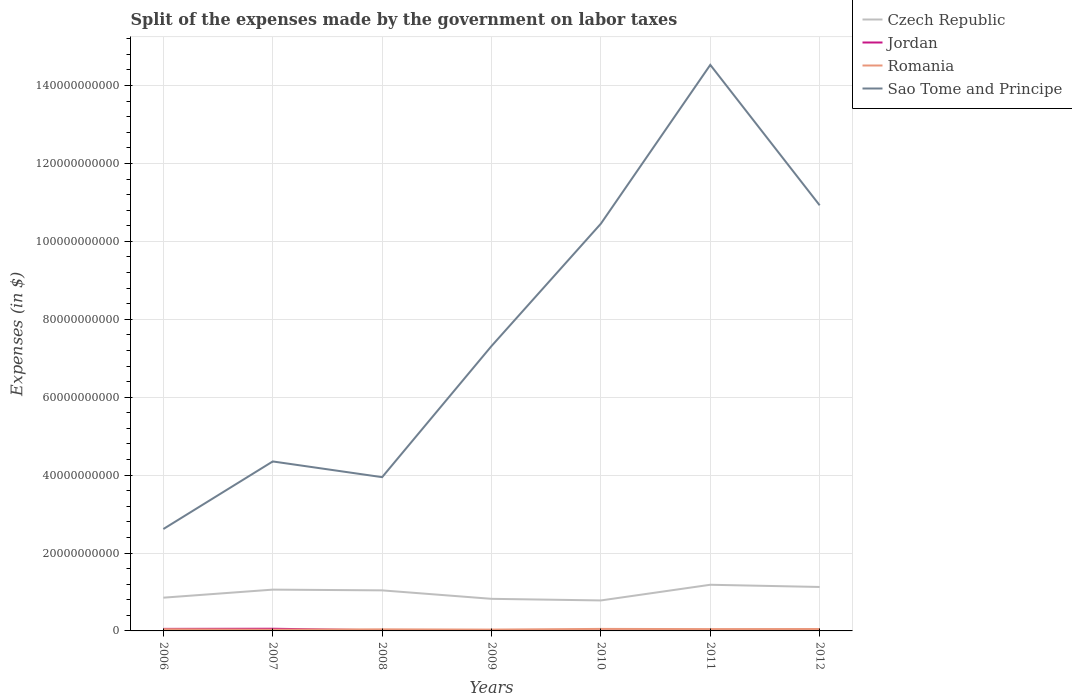How many different coloured lines are there?
Provide a succinct answer. 4. Is the number of lines equal to the number of legend labels?
Your response must be concise. Yes. Across all years, what is the maximum expenses made by the government on labor taxes in Sao Tome and Principe?
Provide a short and direct response. 2.62e+1. In which year was the expenses made by the government on labor taxes in Jordan maximum?
Offer a very short reply. 2011. What is the total expenses made by the government on labor taxes in Sao Tome and Principe in the graph?
Offer a terse response. -4.71e+09. What is the difference between the highest and the second highest expenses made by the government on labor taxes in Czech Republic?
Make the answer very short. 4.02e+09. Is the expenses made by the government on labor taxes in Romania strictly greater than the expenses made by the government on labor taxes in Jordan over the years?
Provide a short and direct response. No. How many lines are there?
Your answer should be very brief. 4. How many years are there in the graph?
Your response must be concise. 7. What is the difference between two consecutive major ticks on the Y-axis?
Offer a terse response. 2.00e+1. Are the values on the major ticks of Y-axis written in scientific E-notation?
Your answer should be very brief. No. Does the graph contain any zero values?
Keep it short and to the point. No. Does the graph contain grids?
Ensure brevity in your answer.  Yes. How many legend labels are there?
Provide a short and direct response. 4. How are the legend labels stacked?
Provide a succinct answer. Vertical. What is the title of the graph?
Your response must be concise. Split of the expenses made by the government on labor taxes. Does "Cuba" appear as one of the legend labels in the graph?
Ensure brevity in your answer.  No. What is the label or title of the X-axis?
Make the answer very short. Years. What is the label or title of the Y-axis?
Offer a very short reply. Expenses (in $). What is the Expenses (in $) in Czech Republic in 2006?
Your answer should be compact. 8.54e+09. What is the Expenses (in $) of Jordan in 2006?
Give a very brief answer. 5.26e+08. What is the Expenses (in $) in Romania in 2006?
Ensure brevity in your answer.  4.42e+08. What is the Expenses (in $) in Sao Tome and Principe in 2006?
Provide a succinct answer. 2.62e+1. What is the Expenses (in $) in Czech Republic in 2007?
Provide a short and direct response. 1.06e+1. What is the Expenses (in $) in Jordan in 2007?
Your response must be concise. 5.62e+08. What is the Expenses (in $) in Romania in 2007?
Give a very brief answer. 3.27e+08. What is the Expenses (in $) in Sao Tome and Principe in 2007?
Ensure brevity in your answer.  4.35e+1. What is the Expenses (in $) in Czech Republic in 2008?
Your answer should be very brief. 1.04e+1. What is the Expenses (in $) in Jordan in 2008?
Ensure brevity in your answer.  1.50e+08. What is the Expenses (in $) of Romania in 2008?
Provide a succinct answer. 4.05e+08. What is the Expenses (in $) in Sao Tome and Principe in 2008?
Your answer should be very brief. 3.95e+1. What is the Expenses (in $) in Czech Republic in 2009?
Offer a terse response. 8.24e+09. What is the Expenses (in $) of Jordan in 2009?
Keep it short and to the point. 1.27e+08. What is the Expenses (in $) in Romania in 2009?
Make the answer very short. 3.41e+08. What is the Expenses (in $) in Sao Tome and Principe in 2009?
Provide a succinct answer. 7.31e+1. What is the Expenses (in $) of Czech Republic in 2010?
Your answer should be compact. 7.82e+09. What is the Expenses (in $) in Jordan in 2010?
Give a very brief answer. 7.79e+07. What is the Expenses (in $) of Romania in 2010?
Your answer should be compact. 5.18e+08. What is the Expenses (in $) in Sao Tome and Principe in 2010?
Offer a very short reply. 1.05e+11. What is the Expenses (in $) of Czech Republic in 2011?
Offer a terse response. 1.18e+1. What is the Expenses (in $) in Jordan in 2011?
Provide a short and direct response. 7.46e+07. What is the Expenses (in $) in Romania in 2011?
Your answer should be very brief. 4.70e+08. What is the Expenses (in $) in Sao Tome and Principe in 2011?
Your answer should be compact. 1.45e+11. What is the Expenses (in $) of Czech Republic in 2012?
Provide a succinct answer. 1.13e+1. What is the Expenses (in $) of Jordan in 2012?
Keep it short and to the point. 1.03e+08. What is the Expenses (in $) of Romania in 2012?
Offer a very short reply. 4.90e+08. What is the Expenses (in $) in Sao Tome and Principe in 2012?
Ensure brevity in your answer.  1.09e+11. Across all years, what is the maximum Expenses (in $) in Czech Republic?
Provide a short and direct response. 1.18e+1. Across all years, what is the maximum Expenses (in $) in Jordan?
Keep it short and to the point. 5.62e+08. Across all years, what is the maximum Expenses (in $) in Romania?
Your response must be concise. 5.18e+08. Across all years, what is the maximum Expenses (in $) in Sao Tome and Principe?
Your response must be concise. 1.45e+11. Across all years, what is the minimum Expenses (in $) in Czech Republic?
Offer a very short reply. 7.82e+09. Across all years, what is the minimum Expenses (in $) in Jordan?
Make the answer very short. 7.46e+07. Across all years, what is the minimum Expenses (in $) in Romania?
Make the answer very short. 3.27e+08. Across all years, what is the minimum Expenses (in $) in Sao Tome and Principe?
Provide a succinct answer. 2.62e+1. What is the total Expenses (in $) of Czech Republic in the graph?
Give a very brief answer. 6.87e+1. What is the total Expenses (in $) in Jordan in the graph?
Keep it short and to the point. 1.62e+09. What is the total Expenses (in $) in Romania in the graph?
Ensure brevity in your answer.  2.99e+09. What is the total Expenses (in $) in Sao Tome and Principe in the graph?
Provide a short and direct response. 5.41e+11. What is the difference between the Expenses (in $) of Czech Republic in 2006 and that in 2007?
Ensure brevity in your answer.  -2.06e+09. What is the difference between the Expenses (in $) in Jordan in 2006 and that in 2007?
Provide a short and direct response. -3.59e+07. What is the difference between the Expenses (in $) of Romania in 2006 and that in 2007?
Your response must be concise. 1.15e+08. What is the difference between the Expenses (in $) of Sao Tome and Principe in 2006 and that in 2007?
Offer a terse response. -1.73e+1. What is the difference between the Expenses (in $) in Czech Republic in 2006 and that in 2008?
Offer a very short reply. -1.88e+09. What is the difference between the Expenses (in $) of Jordan in 2006 and that in 2008?
Offer a terse response. 3.76e+08. What is the difference between the Expenses (in $) in Romania in 2006 and that in 2008?
Give a very brief answer. 3.68e+07. What is the difference between the Expenses (in $) in Sao Tome and Principe in 2006 and that in 2008?
Offer a terse response. -1.33e+1. What is the difference between the Expenses (in $) of Czech Republic in 2006 and that in 2009?
Give a very brief answer. 2.97e+08. What is the difference between the Expenses (in $) in Jordan in 2006 and that in 2009?
Your answer should be compact. 4.00e+08. What is the difference between the Expenses (in $) in Romania in 2006 and that in 2009?
Give a very brief answer. 1.01e+08. What is the difference between the Expenses (in $) in Sao Tome and Principe in 2006 and that in 2009?
Your answer should be compact. -4.70e+1. What is the difference between the Expenses (in $) in Czech Republic in 2006 and that in 2010?
Your answer should be very brief. 7.11e+08. What is the difference between the Expenses (in $) of Jordan in 2006 and that in 2010?
Your answer should be compact. 4.48e+08. What is the difference between the Expenses (in $) of Romania in 2006 and that in 2010?
Provide a short and direct response. -7.61e+07. What is the difference between the Expenses (in $) of Sao Tome and Principe in 2006 and that in 2010?
Your response must be concise. -7.84e+1. What is the difference between the Expenses (in $) of Czech Republic in 2006 and that in 2011?
Provide a succinct answer. -3.31e+09. What is the difference between the Expenses (in $) of Jordan in 2006 and that in 2011?
Ensure brevity in your answer.  4.52e+08. What is the difference between the Expenses (in $) in Romania in 2006 and that in 2011?
Make the answer very short. -2.81e+07. What is the difference between the Expenses (in $) of Sao Tome and Principe in 2006 and that in 2011?
Offer a terse response. -1.19e+11. What is the difference between the Expenses (in $) of Czech Republic in 2006 and that in 2012?
Offer a very short reply. -2.74e+09. What is the difference between the Expenses (in $) of Jordan in 2006 and that in 2012?
Keep it short and to the point. 4.23e+08. What is the difference between the Expenses (in $) of Romania in 2006 and that in 2012?
Your answer should be very brief. -4.77e+07. What is the difference between the Expenses (in $) of Sao Tome and Principe in 2006 and that in 2012?
Make the answer very short. -8.31e+1. What is the difference between the Expenses (in $) in Czech Republic in 2007 and that in 2008?
Offer a terse response. 1.89e+08. What is the difference between the Expenses (in $) of Jordan in 2007 and that in 2008?
Your answer should be very brief. 4.12e+08. What is the difference between the Expenses (in $) in Romania in 2007 and that in 2008?
Provide a short and direct response. -7.81e+07. What is the difference between the Expenses (in $) in Sao Tome and Principe in 2007 and that in 2008?
Your answer should be compact. 4.03e+09. What is the difference between the Expenses (in $) in Czech Republic in 2007 and that in 2009?
Offer a very short reply. 2.36e+09. What is the difference between the Expenses (in $) in Jordan in 2007 and that in 2009?
Ensure brevity in your answer.  4.36e+08. What is the difference between the Expenses (in $) in Romania in 2007 and that in 2009?
Give a very brief answer. -1.39e+07. What is the difference between the Expenses (in $) in Sao Tome and Principe in 2007 and that in 2009?
Give a very brief answer. -2.96e+1. What is the difference between the Expenses (in $) of Czech Republic in 2007 and that in 2010?
Your response must be concise. 2.78e+09. What is the difference between the Expenses (in $) in Jordan in 2007 and that in 2010?
Provide a succinct answer. 4.84e+08. What is the difference between the Expenses (in $) in Romania in 2007 and that in 2010?
Ensure brevity in your answer.  -1.91e+08. What is the difference between the Expenses (in $) of Sao Tome and Principe in 2007 and that in 2010?
Offer a terse response. -6.10e+1. What is the difference between the Expenses (in $) in Czech Republic in 2007 and that in 2011?
Make the answer very short. -1.25e+09. What is the difference between the Expenses (in $) of Jordan in 2007 and that in 2011?
Give a very brief answer. 4.88e+08. What is the difference between the Expenses (in $) of Romania in 2007 and that in 2011?
Provide a succinct answer. -1.43e+08. What is the difference between the Expenses (in $) of Sao Tome and Principe in 2007 and that in 2011?
Offer a very short reply. -1.02e+11. What is the difference between the Expenses (in $) of Czech Republic in 2007 and that in 2012?
Offer a terse response. -6.81e+08. What is the difference between the Expenses (in $) in Jordan in 2007 and that in 2012?
Your response must be concise. 4.59e+08. What is the difference between the Expenses (in $) in Romania in 2007 and that in 2012?
Ensure brevity in your answer.  -1.62e+08. What is the difference between the Expenses (in $) of Sao Tome and Principe in 2007 and that in 2012?
Ensure brevity in your answer.  -6.57e+1. What is the difference between the Expenses (in $) of Czech Republic in 2008 and that in 2009?
Make the answer very short. 2.17e+09. What is the difference between the Expenses (in $) in Jordan in 2008 and that in 2009?
Make the answer very short. 2.38e+07. What is the difference between the Expenses (in $) of Romania in 2008 and that in 2009?
Your answer should be compact. 6.42e+07. What is the difference between the Expenses (in $) in Sao Tome and Principe in 2008 and that in 2009?
Your answer should be very brief. -3.37e+1. What is the difference between the Expenses (in $) of Czech Republic in 2008 and that in 2010?
Your response must be concise. 2.59e+09. What is the difference between the Expenses (in $) in Jordan in 2008 and that in 2010?
Keep it short and to the point. 7.25e+07. What is the difference between the Expenses (in $) in Romania in 2008 and that in 2010?
Provide a succinct answer. -1.13e+08. What is the difference between the Expenses (in $) in Sao Tome and Principe in 2008 and that in 2010?
Ensure brevity in your answer.  -6.51e+1. What is the difference between the Expenses (in $) in Czech Republic in 2008 and that in 2011?
Ensure brevity in your answer.  -1.44e+09. What is the difference between the Expenses (in $) of Jordan in 2008 and that in 2011?
Keep it short and to the point. 7.58e+07. What is the difference between the Expenses (in $) in Romania in 2008 and that in 2011?
Provide a succinct answer. -6.49e+07. What is the difference between the Expenses (in $) of Sao Tome and Principe in 2008 and that in 2011?
Your answer should be very brief. -1.06e+11. What is the difference between the Expenses (in $) in Czech Republic in 2008 and that in 2012?
Give a very brief answer. -8.70e+08. What is the difference between the Expenses (in $) in Jordan in 2008 and that in 2012?
Give a very brief answer. 4.76e+07. What is the difference between the Expenses (in $) in Romania in 2008 and that in 2012?
Offer a very short reply. -8.44e+07. What is the difference between the Expenses (in $) in Sao Tome and Principe in 2008 and that in 2012?
Provide a succinct answer. -6.98e+1. What is the difference between the Expenses (in $) in Czech Republic in 2009 and that in 2010?
Give a very brief answer. 4.14e+08. What is the difference between the Expenses (in $) of Jordan in 2009 and that in 2010?
Your answer should be compact. 4.87e+07. What is the difference between the Expenses (in $) in Romania in 2009 and that in 2010?
Make the answer very short. -1.77e+08. What is the difference between the Expenses (in $) in Sao Tome and Principe in 2009 and that in 2010?
Provide a succinct answer. -3.14e+1. What is the difference between the Expenses (in $) in Czech Republic in 2009 and that in 2011?
Provide a short and direct response. -3.61e+09. What is the difference between the Expenses (in $) of Jordan in 2009 and that in 2011?
Ensure brevity in your answer.  5.20e+07. What is the difference between the Expenses (in $) of Romania in 2009 and that in 2011?
Make the answer very short. -1.29e+08. What is the difference between the Expenses (in $) of Sao Tome and Principe in 2009 and that in 2011?
Offer a very short reply. -7.22e+1. What is the difference between the Expenses (in $) of Czech Republic in 2009 and that in 2012?
Offer a terse response. -3.04e+09. What is the difference between the Expenses (in $) in Jordan in 2009 and that in 2012?
Your answer should be very brief. 2.38e+07. What is the difference between the Expenses (in $) in Romania in 2009 and that in 2012?
Provide a short and direct response. -1.49e+08. What is the difference between the Expenses (in $) in Sao Tome and Principe in 2009 and that in 2012?
Your answer should be very brief. -3.61e+1. What is the difference between the Expenses (in $) in Czech Republic in 2010 and that in 2011?
Your answer should be compact. -4.02e+09. What is the difference between the Expenses (in $) in Jordan in 2010 and that in 2011?
Your answer should be compact. 3.30e+06. What is the difference between the Expenses (in $) in Romania in 2010 and that in 2011?
Your answer should be very brief. 4.80e+07. What is the difference between the Expenses (in $) in Sao Tome and Principe in 2010 and that in 2011?
Give a very brief answer. -4.08e+1. What is the difference between the Expenses (in $) of Czech Republic in 2010 and that in 2012?
Give a very brief answer. -3.46e+09. What is the difference between the Expenses (in $) of Jordan in 2010 and that in 2012?
Provide a succinct answer. -2.49e+07. What is the difference between the Expenses (in $) in Romania in 2010 and that in 2012?
Ensure brevity in your answer.  2.85e+07. What is the difference between the Expenses (in $) in Sao Tome and Principe in 2010 and that in 2012?
Offer a terse response. -4.71e+09. What is the difference between the Expenses (in $) of Czech Republic in 2011 and that in 2012?
Keep it short and to the point. 5.68e+08. What is the difference between the Expenses (in $) of Jordan in 2011 and that in 2012?
Provide a short and direct response. -2.82e+07. What is the difference between the Expenses (in $) in Romania in 2011 and that in 2012?
Offer a terse response. -1.95e+07. What is the difference between the Expenses (in $) in Sao Tome and Principe in 2011 and that in 2012?
Offer a terse response. 3.61e+1. What is the difference between the Expenses (in $) in Czech Republic in 2006 and the Expenses (in $) in Jordan in 2007?
Make the answer very short. 7.97e+09. What is the difference between the Expenses (in $) of Czech Republic in 2006 and the Expenses (in $) of Romania in 2007?
Make the answer very short. 8.21e+09. What is the difference between the Expenses (in $) in Czech Republic in 2006 and the Expenses (in $) in Sao Tome and Principe in 2007?
Provide a succinct answer. -3.50e+1. What is the difference between the Expenses (in $) of Jordan in 2006 and the Expenses (in $) of Romania in 2007?
Your response must be concise. 1.99e+08. What is the difference between the Expenses (in $) in Jordan in 2006 and the Expenses (in $) in Sao Tome and Principe in 2007?
Make the answer very short. -4.30e+1. What is the difference between the Expenses (in $) of Romania in 2006 and the Expenses (in $) of Sao Tome and Principe in 2007?
Give a very brief answer. -4.31e+1. What is the difference between the Expenses (in $) of Czech Republic in 2006 and the Expenses (in $) of Jordan in 2008?
Ensure brevity in your answer.  8.39e+09. What is the difference between the Expenses (in $) of Czech Republic in 2006 and the Expenses (in $) of Romania in 2008?
Provide a succinct answer. 8.13e+09. What is the difference between the Expenses (in $) of Czech Republic in 2006 and the Expenses (in $) of Sao Tome and Principe in 2008?
Your answer should be very brief. -3.09e+1. What is the difference between the Expenses (in $) in Jordan in 2006 and the Expenses (in $) in Romania in 2008?
Keep it short and to the point. 1.21e+08. What is the difference between the Expenses (in $) in Jordan in 2006 and the Expenses (in $) in Sao Tome and Principe in 2008?
Ensure brevity in your answer.  -3.89e+1. What is the difference between the Expenses (in $) of Romania in 2006 and the Expenses (in $) of Sao Tome and Principe in 2008?
Your answer should be compact. -3.90e+1. What is the difference between the Expenses (in $) in Czech Republic in 2006 and the Expenses (in $) in Jordan in 2009?
Ensure brevity in your answer.  8.41e+09. What is the difference between the Expenses (in $) in Czech Republic in 2006 and the Expenses (in $) in Romania in 2009?
Your answer should be very brief. 8.20e+09. What is the difference between the Expenses (in $) of Czech Republic in 2006 and the Expenses (in $) of Sao Tome and Principe in 2009?
Give a very brief answer. -6.46e+1. What is the difference between the Expenses (in $) in Jordan in 2006 and the Expenses (in $) in Romania in 2009?
Ensure brevity in your answer.  1.85e+08. What is the difference between the Expenses (in $) in Jordan in 2006 and the Expenses (in $) in Sao Tome and Principe in 2009?
Your answer should be very brief. -7.26e+1. What is the difference between the Expenses (in $) of Romania in 2006 and the Expenses (in $) of Sao Tome and Principe in 2009?
Provide a succinct answer. -7.27e+1. What is the difference between the Expenses (in $) in Czech Republic in 2006 and the Expenses (in $) in Jordan in 2010?
Your answer should be very brief. 8.46e+09. What is the difference between the Expenses (in $) in Czech Republic in 2006 and the Expenses (in $) in Romania in 2010?
Offer a very short reply. 8.02e+09. What is the difference between the Expenses (in $) of Czech Republic in 2006 and the Expenses (in $) of Sao Tome and Principe in 2010?
Give a very brief answer. -9.60e+1. What is the difference between the Expenses (in $) in Jordan in 2006 and the Expenses (in $) in Romania in 2010?
Provide a succinct answer. 8.28e+06. What is the difference between the Expenses (in $) of Jordan in 2006 and the Expenses (in $) of Sao Tome and Principe in 2010?
Give a very brief answer. -1.04e+11. What is the difference between the Expenses (in $) in Romania in 2006 and the Expenses (in $) in Sao Tome and Principe in 2010?
Offer a terse response. -1.04e+11. What is the difference between the Expenses (in $) of Czech Republic in 2006 and the Expenses (in $) of Jordan in 2011?
Your response must be concise. 8.46e+09. What is the difference between the Expenses (in $) of Czech Republic in 2006 and the Expenses (in $) of Romania in 2011?
Your response must be concise. 8.07e+09. What is the difference between the Expenses (in $) in Czech Republic in 2006 and the Expenses (in $) in Sao Tome and Principe in 2011?
Give a very brief answer. -1.37e+11. What is the difference between the Expenses (in $) in Jordan in 2006 and the Expenses (in $) in Romania in 2011?
Ensure brevity in your answer.  5.63e+07. What is the difference between the Expenses (in $) of Jordan in 2006 and the Expenses (in $) of Sao Tome and Principe in 2011?
Offer a terse response. -1.45e+11. What is the difference between the Expenses (in $) in Romania in 2006 and the Expenses (in $) in Sao Tome and Principe in 2011?
Your answer should be compact. -1.45e+11. What is the difference between the Expenses (in $) of Czech Republic in 2006 and the Expenses (in $) of Jordan in 2012?
Provide a short and direct response. 8.43e+09. What is the difference between the Expenses (in $) in Czech Republic in 2006 and the Expenses (in $) in Romania in 2012?
Your answer should be compact. 8.05e+09. What is the difference between the Expenses (in $) of Czech Republic in 2006 and the Expenses (in $) of Sao Tome and Principe in 2012?
Provide a short and direct response. -1.01e+11. What is the difference between the Expenses (in $) of Jordan in 2006 and the Expenses (in $) of Romania in 2012?
Your answer should be very brief. 3.68e+07. What is the difference between the Expenses (in $) of Jordan in 2006 and the Expenses (in $) of Sao Tome and Principe in 2012?
Your answer should be very brief. -1.09e+11. What is the difference between the Expenses (in $) of Romania in 2006 and the Expenses (in $) of Sao Tome and Principe in 2012?
Offer a very short reply. -1.09e+11. What is the difference between the Expenses (in $) in Czech Republic in 2007 and the Expenses (in $) in Jordan in 2008?
Your response must be concise. 1.04e+1. What is the difference between the Expenses (in $) of Czech Republic in 2007 and the Expenses (in $) of Romania in 2008?
Your answer should be compact. 1.02e+1. What is the difference between the Expenses (in $) of Czech Republic in 2007 and the Expenses (in $) of Sao Tome and Principe in 2008?
Provide a succinct answer. -2.89e+1. What is the difference between the Expenses (in $) in Jordan in 2007 and the Expenses (in $) in Romania in 2008?
Your answer should be compact. 1.57e+08. What is the difference between the Expenses (in $) of Jordan in 2007 and the Expenses (in $) of Sao Tome and Principe in 2008?
Provide a short and direct response. -3.89e+1. What is the difference between the Expenses (in $) in Romania in 2007 and the Expenses (in $) in Sao Tome and Principe in 2008?
Ensure brevity in your answer.  -3.91e+1. What is the difference between the Expenses (in $) of Czech Republic in 2007 and the Expenses (in $) of Jordan in 2009?
Your answer should be very brief. 1.05e+1. What is the difference between the Expenses (in $) of Czech Republic in 2007 and the Expenses (in $) of Romania in 2009?
Make the answer very short. 1.03e+1. What is the difference between the Expenses (in $) in Czech Republic in 2007 and the Expenses (in $) in Sao Tome and Principe in 2009?
Offer a terse response. -6.25e+1. What is the difference between the Expenses (in $) of Jordan in 2007 and the Expenses (in $) of Romania in 2009?
Your response must be concise. 2.21e+08. What is the difference between the Expenses (in $) of Jordan in 2007 and the Expenses (in $) of Sao Tome and Principe in 2009?
Offer a very short reply. -7.26e+1. What is the difference between the Expenses (in $) of Romania in 2007 and the Expenses (in $) of Sao Tome and Principe in 2009?
Your response must be concise. -7.28e+1. What is the difference between the Expenses (in $) of Czech Republic in 2007 and the Expenses (in $) of Jordan in 2010?
Offer a terse response. 1.05e+1. What is the difference between the Expenses (in $) of Czech Republic in 2007 and the Expenses (in $) of Romania in 2010?
Make the answer very short. 1.01e+1. What is the difference between the Expenses (in $) in Czech Republic in 2007 and the Expenses (in $) in Sao Tome and Principe in 2010?
Provide a short and direct response. -9.40e+1. What is the difference between the Expenses (in $) of Jordan in 2007 and the Expenses (in $) of Romania in 2010?
Make the answer very short. 4.42e+07. What is the difference between the Expenses (in $) of Jordan in 2007 and the Expenses (in $) of Sao Tome and Principe in 2010?
Ensure brevity in your answer.  -1.04e+11. What is the difference between the Expenses (in $) in Romania in 2007 and the Expenses (in $) in Sao Tome and Principe in 2010?
Your answer should be very brief. -1.04e+11. What is the difference between the Expenses (in $) of Czech Republic in 2007 and the Expenses (in $) of Jordan in 2011?
Your answer should be compact. 1.05e+1. What is the difference between the Expenses (in $) of Czech Republic in 2007 and the Expenses (in $) of Romania in 2011?
Ensure brevity in your answer.  1.01e+1. What is the difference between the Expenses (in $) of Czech Republic in 2007 and the Expenses (in $) of Sao Tome and Principe in 2011?
Offer a terse response. -1.35e+11. What is the difference between the Expenses (in $) in Jordan in 2007 and the Expenses (in $) in Romania in 2011?
Keep it short and to the point. 9.22e+07. What is the difference between the Expenses (in $) in Jordan in 2007 and the Expenses (in $) in Sao Tome and Principe in 2011?
Your response must be concise. -1.45e+11. What is the difference between the Expenses (in $) of Romania in 2007 and the Expenses (in $) of Sao Tome and Principe in 2011?
Make the answer very short. -1.45e+11. What is the difference between the Expenses (in $) of Czech Republic in 2007 and the Expenses (in $) of Jordan in 2012?
Keep it short and to the point. 1.05e+1. What is the difference between the Expenses (in $) of Czech Republic in 2007 and the Expenses (in $) of Romania in 2012?
Ensure brevity in your answer.  1.01e+1. What is the difference between the Expenses (in $) in Czech Republic in 2007 and the Expenses (in $) in Sao Tome and Principe in 2012?
Provide a short and direct response. -9.87e+1. What is the difference between the Expenses (in $) of Jordan in 2007 and the Expenses (in $) of Romania in 2012?
Keep it short and to the point. 7.27e+07. What is the difference between the Expenses (in $) of Jordan in 2007 and the Expenses (in $) of Sao Tome and Principe in 2012?
Provide a succinct answer. -1.09e+11. What is the difference between the Expenses (in $) of Romania in 2007 and the Expenses (in $) of Sao Tome and Principe in 2012?
Ensure brevity in your answer.  -1.09e+11. What is the difference between the Expenses (in $) of Czech Republic in 2008 and the Expenses (in $) of Jordan in 2009?
Your response must be concise. 1.03e+1. What is the difference between the Expenses (in $) in Czech Republic in 2008 and the Expenses (in $) in Romania in 2009?
Keep it short and to the point. 1.01e+1. What is the difference between the Expenses (in $) of Czech Republic in 2008 and the Expenses (in $) of Sao Tome and Principe in 2009?
Provide a short and direct response. -6.27e+1. What is the difference between the Expenses (in $) in Jordan in 2008 and the Expenses (in $) in Romania in 2009?
Provide a succinct answer. -1.90e+08. What is the difference between the Expenses (in $) in Jordan in 2008 and the Expenses (in $) in Sao Tome and Principe in 2009?
Provide a short and direct response. -7.30e+1. What is the difference between the Expenses (in $) of Romania in 2008 and the Expenses (in $) of Sao Tome and Principe in 2009?
Give a very brief answer. -7.27e+1. What is the difference between the Expenses (in $) in Czech Republic in 2008 and the Expenses (in $) in Jordan in 2010?
Your answer should be compact. 1.03e+1. What is the difference between the Expenses (in $) of Czech Republic in 2008 and the Expenses (in $) of Romania in 2010?
Keep it short and to the point. 9.89e+09. What is the difference between the Expenses (in $) in Czech Republic in 2008 and the Expenses (in $) in Sao Tome and Principe in 2010?
Keep it short and to the point. -9.41e+1. What is the difference between the Expenses (in $) of Jordan in 2008 and the Expenses (in $) of Romania in 2010?
Your answer should be compact. -3.68e+08. What is the difference between the Expenses (in $) in Jordan in 2008 and the Expenses (in $) in Sao Tome and Principe in 2010?
Make the answer very short. -1.04e+11. What is the difference between the Expenses (in $) in Romania in 2008 and the Expenses (in $) in Sao Tome and Principe in 2010?
Offer a very short reply. -1.04e+11. What is the difference between the Expenses (in $) in Czech Republic in 2008 and the Expenses (in $) in Jordan in 2011?
Provide a short and direct response. 1.03e+1. What is the difference between the Expenses (in $) in Czech Republic in 2008 and the Expenses (in $) in Romania in 2011?
Keep it short and to the point. 9.94e+09. What is the difference between the Expenses (in $) of Czech Republic in 2008 and the Expenses (in $) of Sao Tome and Principe in 2011?
Make the answer very short. -1.35e+11. What is the difference between the Expenses (in $) of Jordan in 2008 and the Expenses (in $) of Romania in 2011?
Offer a terse response. -3.20e+08. What is the difference between the Expenses (in $) in Jordan in 2008 and the Expenses (in $) in Sao Tome and Principe in 2011?
Offer a terse response. -1.45e+11. What is the difference between the Expenses (in $) of Romania in 2008 and the Expenses (in $) of Sao Tome and Principe in 2011?
Keep it short and to the point. -1.45e+11. What is the difference between the Expenses (in $) in Czech Republic in 2008 and the Expenses (in $) in Jordan in 2012?
Your answer should be very brief. 1.03e+1. What is the difference between the Expenses (in $) of Czech Republic in 2008 and the Expenses (in $) of Romania in 2012?
Make the answer very short. 9.92e+09. What is the difference between the Expenses (in $) in Czech Republic in 2008 and the Expenses (in $) in Sao Tome and Principe in 2012?
Offer a very short reply. -9.88e+1. What is the difference between the Expenses (in $) in Jordan in 2008 and the Expenses (in $) in Romania in 2012?
Offer a very short reply. -3.39e+08. What is the difference between the Expenses (in $) in Jordan in 2008 and the Expenses (in $) in Sao Tome and Principe in 2012?
Offer a very short reply. -1.09e+11. What is the difference between the Expenses (in $) of Romania in 2008 and the Expenses (in $) of Sao Tome and Principe in 2012?
Offer a terse response. -1.09e+11. What is the difference between the Expenses (in $) of Czech Republic in 2009 and the Expenses (in $) of Jordan in 2010?
Your response must be concise. 8.16e+09. What is the difference between the Expenses (in $) of Czech Republic in 2009 and the Expenses (in $) of Romania in 2010?
Offer a very short reply. 7.72e+09. What is the difference between the Expenses (in $) of Czech Republic in 2009 and the Expenses (in $) of Sao Tome and Principe in 2010?
Keep it short and to the point. -9.63e+1. What is the difference between the Expenses (in $) of Jordan in 2009 and the Expenses (in $) of Romania in 2010?
Give a very brief answer. -3.91e+08. What is the difference between the Expenses (in $) in Jordan in 2009 and the Expenses (in $) in Sao Tome and Principe in 2010?
Your response must be concise. -1.04e+11. What is the difference between the Expenses (in $) of Romania in 2009 and the Expenses (in $) of Sao Tome and Principe in 2010?
Your answer should be compact. -1.04e+11. What is the difference between the Expenses (in $) of Czech Republic in 2009 and the Expenses (in $) of Jordan in 2011?
Give a very brief answer. 8.16e+09. What is the difference between the Expenses (in $) in Czech Republic in 2009 and the Expenses (in $) in Romania in 2011?
Provide a succinct answer. 7.77e+09. What is the difference between the Expenses (in $) in Czech Republic in 2009 and the Expenses (in $) in Sao Tome and Principe in 2011?
Provide a short and direct response. -1.37e+11. What is the difference between the Expenses (in $) in Jordan in 2009 and the Expenses (in $) in Romania in 2011?
Offer a very short reply. -3.43e+08. What is the difference between the Expenses (in $) of Jordan in 2009 and the Expenses (in $) of Sao Tome and Principe in 2011?
Provide a succinct answer. -1.45e+11. What is the difference between the Expenses (in $) in Romania in 2009 and the Expenses (in $) in Sao Tome and Principe in 2011?
Make the answer very short. -1.45e+11. What is the difference between the Expenses (in $) in Czech Republic in 2009 and the Expenses (in $) in Jordan in 2012?
Your answer should be very brief. 8.14e+09. What is the difference between the Expenses (in $) of Czech Republic in 2009 and the Expenses (in $) of Romania in 2012?
Offer a very short reply. 7.75e+09. What is the difference between the Expenses (in $) in Czech Republic in 2009 and the Expenses (in $) in Sao Tome and Principe in 2012?
Your answer should be very brief. -1.01e+11. What is the difference between the Expenses (in $) of Jordan in 2009 and the Expenses (in $) of Romania in 2012?
Provide a succinct answer. -3.63e+08. What is the difference between the Expenses (in $) in Jordan in 2009 and the Expenses (in $) in Sao Tome and Principe in 2012?
Provide a short and direct response. -1.09e+11. What is the difference between the Expenses (in $) of Romania in 2009 and the Expenses (in $) of Sao Tome and Principe in 2012?
Make the answer very short. -1.09e+11. What is the difference between the Expenses (in $) in Czech Republic in 2010 and the Expenses (in $) in Jordan in 2011?
Give a very brief answer. 7.75e+09. What is the difference between the Expenses (in $) in Czech Republic in 2010 and the Expenses (in $) in Romania in 2011?
Make the answer very short. 7.36e+09. What is the difference between the Expenses (in $) of Czech Republic in 2010 and the Expenses (in $) of Sao Tome and Principe in 2011?
Offer a terse response. -1.37e+11. What is the difference between the Expenses (in $) in Jordan in 2010 and the Expenses (in $) in Romania in 2011?
Give a very brief answer. -3.92e+08. What is the difference between the Expenses (in $) of Jordan in 2010 and the Expenses (in $) of Sao Tome and Principe in 2011?
Your answer should be very brief. -1.45e+11. What is the difference between the Expenses (in $) of Romania in 2010 and the Expenses (in $) of Sao Tome and Principe in 2011?
Provide a succinct answer. -1.45e+11. What is the difference between the Expenses (in $) of Czech Republic in 2010 and the Expenses (in $) of Jordan in 2012?
Your answer should be very brief. 7.72e+09. What is the difference between the Expenses (in $) in Czech Republic in 2010 and the Expenses (in $) in Romania in 2012?
Make the answer very short. 7.34e+09. What is the difference between the Expenses (in $) in Czech Republic in 2010 and the Expenses (in $) in Sao Tome and Principe in 2012?
Ensure brevity in your answer.  -1.01e+11. What is the difference between the Expenses (in $) of Jordan in 2010 and the Expenses (in $) of Romania in 2012?
Your answer should be very brief. -4.12e+08. What is the difference between the Expenses (in $) of Jordan in 2010 and the Expenses (in $) of Sao Tome and Principe in 2012?
Give a very brief answer. -1.09e+11. What is the difference between the Expenses (in $) of Romania in 2010 and the Expenses (in $) of Sao Tome and Principe in 2012?
Your answer should be very brief. -1.09e+11. What is the difference between the Expenses (in $) in Czech Republic in 2011 and the Expenses (in $) in Jordan in 2012?
Your response must be concise. 1.17e+1. What is the difference between the Expenses (in $) in Czech Republic in 2011 and the Expenses (in $) in Romania in 2012?
Give a very brief answer. 1.14e+1. What is the difference between the Expenses (in $) of Czech Republic in 2011 and the Expenses (in $) of Sao Tome and Principe in 2012?
Give a very brief answer. -9.74e+1. What is the difference between the Expenses (in $) of Jordan in 2011 and the Expenses (in $) of Romania in 2012?
Keep it short and to the point. -4.15e+08. What is the difference between the Expenses (in $) in Jordan in 2011 and the Expenses (in $) in Sao Tome and Principe in 2012?
Ensure brevity in your answer.  -1.09e+11. What is the difference between the Expenses (in $) in Romania in 2011 and the Expenses (in $) in Sao Tome and Principe in 2012?
Offer a very short reply. -1.09e+11. What is the average Expenses (in $) in Czech Republic per year?
Your answer should be very brief. 9.82e+09. What is the average Expenses (in $) in Jordan per year?
Provide a succinct answer. 2.32e+08. What is the average Expenses (in $) of Romania per year?
Make the answer very short. 4.27e+08. What is the average Expenses (in $) in Sao Tome and Principe per year?
Offer a terse response. 7.73e+1. In the year 2006, what is the difference between the Expenses (in $) in Czech Republic and Expenses (in $) in Jordan?
Give a very brief answer. 8.01e+09. In the year 2006, what is the difference between the Expenses (in $) in Czech Republic and Expenses (in $) in Romania?
Provide a short and direct response. 8.09e+09. In the year 2006, what is the difference between the Expenses (in $) in Czech Republic and Expenses (in $) in Sao Tome and Principe?
Offer a very short reply. -1.76e+1. In the year 2006, what is the difference between the Expenses (in $) in Jordan and Expenses (in $) in Romania?
Provide a short and direct response. 8.44e+07. In the year 2006, what is the difference between the Expenses (in $) of Jordan and Expenses (in $) of Sao Tome and Principe?
Your answer should be compact. -2.56e+1. In the year 2006, what is the difference between the Expenses (in $) in Romania and Expenses (in $) in Sao Tome and Principe?
Offer a very short reply. -2.57e+1. In the year 2007, what is the difference between the Expenses (in $) of Czech Republic and Expenses (in $) of Jordan?
Your answer should be very brief. 1.00e+1. In the year 2007, what is the difference between the Expenses (in $) of Czech Republic and Expenses (in $) of Romania?
Provide a succinct answer. 1.03e+1. In the year 2007, what is the difference between the Expenses (in $) of Czech Republic and Expenses (in $) of Sao Tome and Principe?
Make the answer very short. -3.29e+1. In the year 2007, what is the difference between the Expenses (in $) of Jordan and Expenses (in $) of Romania?
Offer a very short reply. 2.35e+08. In the year 2007, what is the difference between the Expenses (in $) in Jordan and Expenses (in $) in Sao Tome and Principe?
Provide a succinct answer. -4.29e+1. In the year 2007, what is the difference between the Expenses (in $) of Romania and Expenses (in $) of Sao Tome and Principe?
Offer a very short reply. -4.32e+1. In the year 2008, what is the difference between the Expenses (in $) in Czech Republic and Expenses (in $) in Jordan?
Ensure brevity in your answer.  1.03e+1. In the year 2008, what is the difference between the Expenses (in $) of Czech Republic and Expenses (in $) of Romania?
Your answer should be compact. 1.00e+1. In the year 2008, what is the difference between the Expenses (in $) in Czech Republic and Expenses (in $) in Sao Tome and Principe?
Your answer should be very brief. -2.91e+1. In the year 2008, what is the difference between the Expenses (in $) of Jordan and Expenses (in $) of Romania?
Keep it short and to the point. -2.55e+08. In the year 2008, what is the difference between the Expenses (in $) in Jordan and Expenses (in $) in Sao Tome and Principe?
Your answer should be compact. -3.93e+1. In the year 2008, what is the difference between the Expenses (in $) in Romania and Expenses (in $) in Sao Tome and Principe?
Your answer should be compact. -3.91e+1. In the year 2009, what is the difference between the Expenses (in $) in Czech Republic and Expenses (in $) in Jordan?
Make the answer very short. 8.11e+09. In the year 2009, what is the difference between the Expenses (in $) of Czech Republic and Expenses (in $) of Romania?
Give a very brief answer. 7.90e+09. In the year 2009, what is the difference between the Expenses (in $) of Czech Republic and Expenses (in $) of Sao Tome and Principe?
Offer a terse response. -6.49e+1. In the year 2009, what is the difference between the Expenses (in $) of Jordan and Expenses (in $) of Romania?
Give a very brief answer. -2.14e+08. In the year 2009, what is the difference between the Expenses (in $) of Jordan and Expenses (in $) of Sao Tome and Principe?
Ensure brevity in your answer.  -7.30e+1. In the year 2009, what is the difference between the Expenses (in $) of Romania and Expenses (in $) of Sao Tome and Principe?
Make the answer very short. -7.28e+1. In the year 2010, what is the difference between the Expenses (in $) in Czech Republic and Expenses (in $) in Jordan?
Offer a very short reply. 7.75e+09. In the year 2010, what is the difference between the Expenses (in $) of Czech Republic and Expenses (in $) of Romania?
Your response must be concise. 7.31e+09. In the year 2010, what is the difference between the Expenses (in $) in Czech Republic and Expenses (in $) in Sao Tome and Principe?
Offer a terse response. -9.67e+1. In the year 2010, what is the difference between the Expenses (in $) of Jordan and Expenses (in $) of Romania?
Keep it short and to the point. -4.40e+08. In the year 2010, what is the difference between the Expenses (in $) of Jordan and Expenses (in $) of Sao Tome and Principe?
Offer a very short reply. -1.04e+11. In the year 2010, what is the difference between the Expenses (in $) of Romania and Expenses (in $) of Sao Tome and Principe?
Your answer should be very brief. -1.04e+11. In the year 2011, what is the difference between the Expenses (in $) in Czech Republic and Expenses (in $) in Jordan?
Provide a succinct answer. 1.18e+1. In the year 2011, what is the difference between the Expenses (in $) of Czech Republic and Expenses (in $) of Romania?
Ensure brevity in your answer.  1.14e+1. In the year 2011, what is the difference between the Expenses (in $) of Czech Republic and Expenses (in $) of Sao Tome and Principe?
Offer a very short reply. -1.33e+11. In the year 2011, what is the difference between the Expenses (in $) in Jordan and Expenses (in $) in Romania?
Keep it short and to the point. -3.95e+08. In the year 2011, what is the difference between the Expenses (in $) of Jordan and Expenses (in $) of Sao Tome and Principe?
Ensure brevity in your answer.  -1.45e+11. In the year 2011, what is the difference between the Expenses (in $) in Romania and Expenses (in $) in Sao Tome and Principe?
Offer a terse response. -1.45e+11. In the year 2012, what is the difference between the Expenses (in $) of Czech Republic and Expenses (in $) of Jordan?
Keep it short and to the point. 1.12e+1. In the year 2012, what is the difference between the Expenses (in $) in Czech Republic and Expenses (in $) in Romania?
Make the answer very short. 1.08e+1. In the year 2012, what is the difference between the Expenses (in $) in Czech Republic and Expenses (in $) in Sao Tome and Principe?
Your response must be concise. -9.80e+1. In the year 2012, what is the difference between the Expenses (in $) of Jordan and Expenses (in $) of Romania?
Make the answer very short. -3.87e+08. In the year 2012, what is the difference between the Expenses (in $) of Jordan and Expenses (in $) of Sao Tome and Principe?
Your answer should be very brief. -1.09e+11. In the year 2012, what is the difference between the Expenses (in $) of Romania and Expenses (in $) of Sao Tome and Principe?
Give a very brief answer. -1.09e+11. What is the ratio of the Expenses (in $) in Czech Republic in 2006 to that in 2007?
Your response must be concise. 0.81. What is the ratio of the Expenses (in $) in Jordan in 2006 to that in 2007?
Keep it short and to the point. 0.94. What is the ratio of the Expenses (in $) in Romania in 2006 to that in 2007?
Provide a short and direct response. 1.35. What is the ratio of the Expenses (in $) in Sao Tome and Principe in 2006 to that in 2007?
Ensure brevity in your answer.  0.6. What is the ratio of the Expenses (in $) of Czech Republic in 2006 to that in 2008?
Give a very brief answer. 0.82. What is the ratio of the Expenses (in $) of Jordan in 2006 to that in 2008?
Give a very brief answer. 3.5. What is the ratio of the Expenses (in $) in Romania in 2006 to that in 2008?
Provide a short and direct response. 1.09. What is the ratio of the Expenses (in $) of Sao Tome and Principe in 2006 to that in 2008?
Keep it short and to the point. 0.66. What is the ratio of the Expenses (in $) in Czech Republic in 2006 to that in 2009?
Offer a terse response. 1.04. What is the ratio of the Expenses (in $) of Jordan in 2006 to that in 2009?
Your answer should be compact. 4.16. What is the ratio of the Expenses (in $) of Romania in 2006 to that in 2009?
Ensure brevity in your answer.  1.3. What is the ratio of the Expenses (in $) of Sao Tome and Principe in 2006 to that in 2009?
Make the answer very short. 0.36. What is the ratio of the Expenses (in $) of Jordan in 2006 to that in 2010?
Ensure brevity in your answer.  6.76. What is the ratio of the Expenses (in $) in Romania in 2006 to that in 2010?
Provide a succinct answer. 0.85. What is the ratio of the Expenses (in $) of Sao Tome and Principe in 2006 to that in 2010?
Offer a very short reply. 0.25. What is the ratio of the Expenses (in $) in Czech Republic in 2006 to that in 2011?
Your answer should be compact. 0.72. What is the ratio of the Expenses (in $) of Jordan in 2006 to that in 2011?
Make the answer very short. 7.05. What is the ratio of the Expenses (in $) in Romania in 2006 to that in 2011?
Provide a succinct answer. 0.94. What is the ratio of the Expenses (in $) in Sao Tome and Principe in 2006 to that in 2011?
Keep it short and to the point. 0.18. What is the ratio of the Expenses (in $) in Czech Republic in 2006 to that in 2012?
Keep it short and to the point. 0.76. What is the ratio of the Expenses (in $) in Jordan in 2006 to that in 2012?
Your response must be concise. 5.12. What is the ratio of the Expenses (in $) in Romania in 2006 to that in 2012?
Your answer should be very brief. 0.9. What is the ratio of the Expenses (in $) in Sao Tome and Principe in 2006 to that in 2012?
Ensure brevity in your answer.  0.24. What is the ratio of the Expenses (in $) in Czech Republic in 2007 to that in 2008?
Your answer should be very brief. 1.02. What is the ratio of the Expenses (in $) in Jordan in 2007 to that in 2008?
Make the answer very short. 3.74. What is the ratio of the Expenses (in $) of Romania in 2007 to that in 2008?
Keep it short and to the point. 0.81. What is the ratio of the Expenses (in $) of Sao Tome and Principe in 2007 to that in 2008?
Your answer should be very brief. 1.1. What is the ratio of the Expenses (in $) in Czech Republic in 2007 to that in 2009?
Your answer should be compact. 1.29. What is the ratio of the Expenses (in $) in Jordan in 2007 to that in 2009?
Ensure brevity in your answer.  4.44. What is the ratio of the Expenses (in $) of Romania in 2007 to that in 2009?
Your answer should be compact. 0.96. What is the ratio of the Expenses (in $) in Sao Tome and Principe in 2007 to that in 2009?
Give a very brief answer. 0.59. What is the ratio of the Expenses (in $) in Czech Republic in 2007 to that in 2010?
Offer a terse response. 1.35. What is the ratio of the Expenses (in $) in Jordan in 2007 to that in 2010?
Offer a very short reply. 7.22. What is the ratio of the Expenses (in $) of Romania in 2007 to that in 2010?
Your answer should be compact. 0.63. What is the ratio of the Expenses (in $) of Sao Tome and Principe in 2007 to that in 2010?
Provide a short and direct response. 0.42. What is the ratio of the Expenses (in $) in Czech Republic in 2007 to that in 2011?
Provide a succinct answer. 0.89. What is the ratio of the Expenses (in $) of Jordan in 2007 to that in 2011?
Offer a terse response. 7.54. What is the ratio of the Expenses (in $) in Romania in 2007 to that in 2011?
Offer a very short reply. 0.7. What is the ratio of the Expenses (in $) of Sao Tome and Principe in 2007 to that in 2011?
Your answer should be very brief. 0.3. What is the ratio of the Expenses (in $) in Czech Republic in 2007 to that in 2012?
Your answer should be very brief. 0.94. What is the ratio of the Expenses (in $) in Jordan in 2007 to that in 2012?
Ensure brevity in your answer.  5.47. What is the ratio of the Expenses (in $) in Romania in 2007 to that in 2012?
Give a very brief answer. 0.67. What is the ratio of the Expenses (in $) in Sao Tome and Principe in 2007 to that in 2012?
Keep it short and to the point. 0.4. What is the ratio of the Expenses (in $) in Czech Republic in 2008 to that in 2009?
Provide a succinct answer. 1.26. What is the ratio of the Expenses (in $) of Jordan in 2008 to that in 2009?
Keep it short and to the point. 1.19. What is the ratio of the Expenses (in $) in Romania in 2008 to that in 2009?
Give a very brief answer. 1.19. What is the ratio of the Expenses (in $) in Sao Tome and Principe in 2008 to that in 2009?
Keep it short and to the point. 0.54. What is the ratio of the Expenses (in $) of Czech Republic in 2008 to that in 2010?
Keep it short and to the point. 1.33. What is the ratio of the Expenses (in $) of Jordan in 2008 to that in 2010?
Ensure brevity in your answer.  1.93. What is the ratio of the Expenses (in $) of Romania in 2008 to that in 2010?
Your answer should be very brief. 0.78. What is the ratio of the Expenses (in $) of Sao Tome and Principe in 2008 to that in 2010?
Ensure brevity in your answer.  0.38. What is the ratio of the Expenses (in $) in Czech Republic in 2008 to that in 2011?
Give a very brief answer. 0.88. What is the ratio of the Expenses (in $) of Jordan in 2008 to that in 2011?
Your answer should be very brief. 2.02. What is the ratio of the Expenses (in $) in Romania in 2008 to that in 2011?
Give a very brief answer. 0.86. What is the ratio of the Expenses (in $) of Sao Tome and Principe in 2008 to that in 2011?
Provide a short and direct response. 0.27. What is the ratio of the Expenses (in $) of Czech Republic in 2008 to that in 2012?
Keep it short and to the point. 0.92. What is the ratio of the Expenses (in $) of Jordan in 2008 to that in 2012?
Provide a succinct answer. 1.46. What is the ratio of the Expenses (in $) in Romania in 2008 to that in 2012?
Offer a terse response. 0.83. What is the ratio of the Expenses (in $) in Sao Tome and Principe in 2008 to that in 2012?
Provide a short and direct response. 0.36. What is the ratio of the Expenses (in $) in Czech Republic in 2009 to that in 2010?
Your answer should be very brief. 1.05. What is the ratio of the Expenses (in $) of Jordan in 2009 to that in 2010?
Provide a short and direct response. 1.63. What is the ratio of the Expenses (in $) in Romania in 2009 to that in 2010?
Your answer should be compact. 0.66. What is the ratio of the Expenses (in $) in Sao Tome and Principe in 2009 to that in 2010?
Make the answer very short. 0.7. What is the ratio of the Expenses (in $) of Czech Republic in 2009 to that in 2011?
Ensure brevity in your answer.  0.7. What is the ratio of the Expenses (in $) in Jordan in 2009 to that in 2011?
Your answer should be compact. 1.7. What is the ratio of the Expenses (in $) in Romania in 2009 to that in 2011?
Provide a short and direct response. 0.73. What is the ratio of the Expenses (in $) of Sao Tome and Principe in 2009 to that in 2011?
Your answer should be very brief. 0.5. What is the ratio of the Expenses (in $) in Czech Republic in 2009 to that in 2012?
Offer a very short reply. 0.73. What is the ratio of the Expenses (in $) in Jordan in 2009 to that in 2012?
Give a very brief answer. 1.23. What is the ratio of the Expenses (in $) of Romania in 2009 to that in 2012?
Provide a succinct answer. 0.7. What is the ratio of the Expenses (in $) of Sao Tome and Principe in 2009 to that in 2012?
Offer a very short reply. 0.67. What is the ratio of the Expenses (in $) in Czech Republic in 2010 to that in 2011?
Ensure brevity in your answer.  0.66. What is the ratio of the Expenses (in $) of Jordan in 2010 to that in 2011?
Your answer should be compact. 1.04. What is the ratio of the Expenses (in $) in Romania in 2010 to that in 2011?
Your response must be concise. 1.1. What is the ratio of the Expenses (in $) in Sao Tome and Principe in 2010 to that in 2011?
Provide a succinct answer. 0.72. What is the ratio of the Expenses (in $) of Czech Republic in 2010 to that in 2012?
Offer a very short reply. 0.69. What is the ratio of the Expenses (in $) of Jordan in 2010 to that in 2012?
Provide a succinct answer. 0.76. What is the ratio of the Expenses (in $) in Romania in 2010 to that in 2012?
Give a very brief answer. 1.06. What is the ratio of the Expenses (in $) in Sao Tome and Principe in 2010 to that in 2012?
Your response must be concise. 0.96. What is the ratio of the Expenses (in $) of Czech Republic in 2011 to that in 2012?
Give a very brief answer. 1.05. What is the ratio of the Expenses (in $) in Jordan in 2011 to that in 2012?
Your response must be concise. 0.73. What is the ratio of the Expenses (in $) in Romania in 2011 to that in 2012?
Your response must be concise. 0.96. What is the ratio of the Expenses (in $) in Sao Tome and Principe in 2011 to that in 2012?
Offer a terse response. 1.33. What is the difference between the highest and the second highest Expenses (in $) of Czech Republic?
Ensure brevity in your answer.  5.68e+08. What is the difference between the highest and the second highest Expenses (in $) in Jordan?
Offer a very short reply. 3.59e+07. What is the difference between the highest and the second highest Expenses (in $) in Romania?
Ensure brevity in your answer.  2.85e+07. What is the difference between the highest and the second highest Expenses (in $) of Sao Tome and Principe?
Your answer should be compact. 3.61e+1. What is the difference between the highest and the lowest Expenses (in $) of Czech Republic?
Provide a succinct answer. 4.02e+09. What is the difference between the highest and the lowest Expenses (in $) of Jordan?
Keep it short and to the point. 4.88e+08. What is the difference between the highest and the lowest Expenses (in $) of Romania?
Keep it short and to the point. 1.91e+08. What is the difference between the highest and the lowest Expenses (in $) of Sao Tome and Principe?
Make the answer very short. 1.19e+11. 